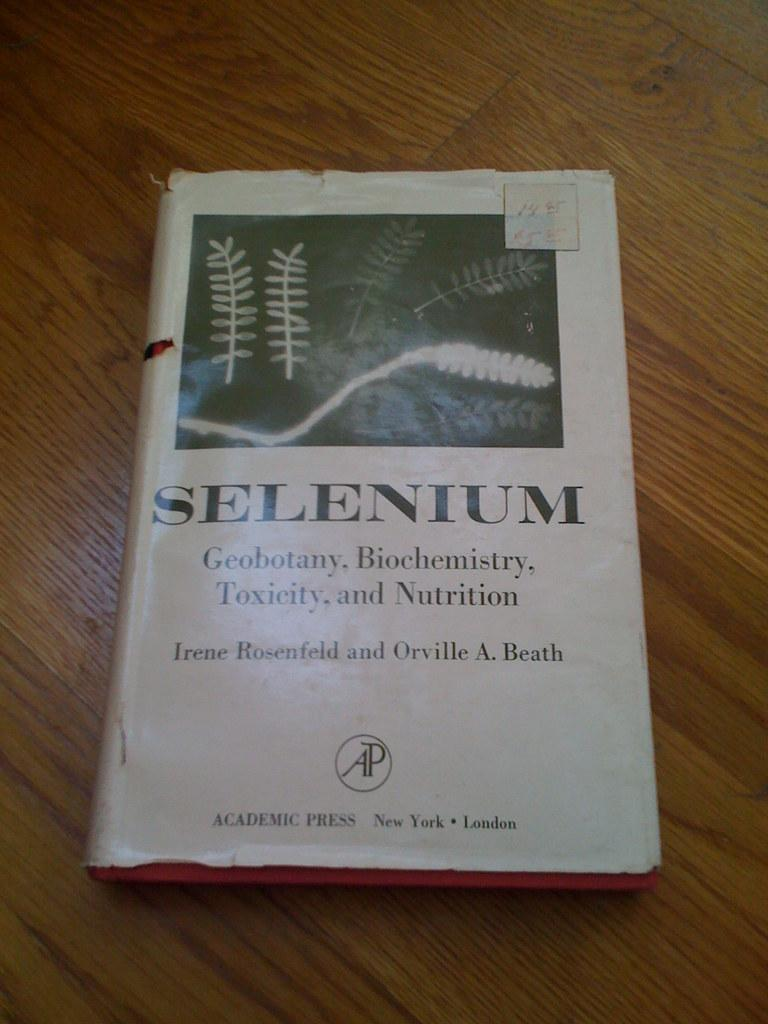<image>
Render a clear and concise summary of the photo. A book about Selenium has pages whose edges are red. 